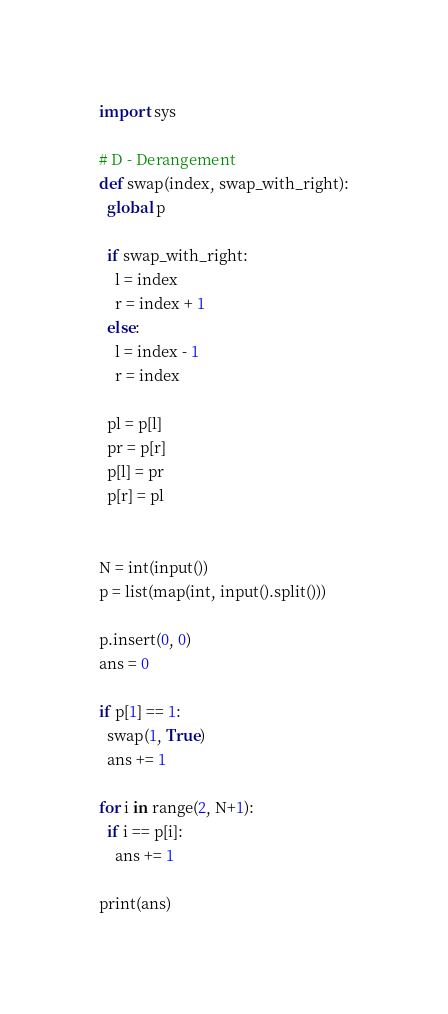<code> <loc_0><loc_0><loc_500><loc_500><_Python_>import sys

# D - Derangement
def swap(index, swap_with_right):
  global p

  if swap_with_right:
    l = index
    r = index + 1
  else:
    l = index - 1
    r = index

  pl = p[l]
  pr = p[r]
  p[l] = pr
  p[r] = pl


N = int(input())
p = list(map(int, input().split()))

p.insert(0, 0)
ans = 0

if p[1] == 1:
  swap(1, True)
  ans += 1

for i in range(2, N+1):
  if i == p[i]:
    ans += 1

print(ans)</code> 